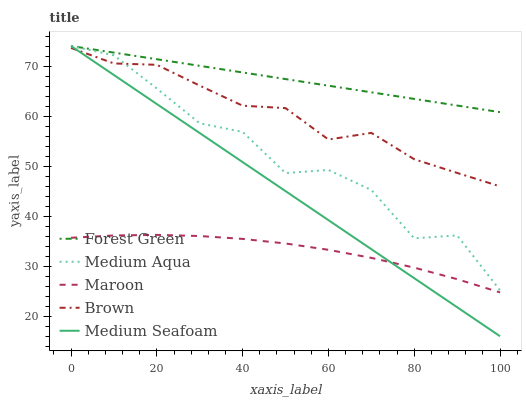Does Maroon have the minimum area under the curve?
Answer yes or no. Yes. Does Forest Green have the maximum area under the curve?
Answer yes or no. Yes. Does Medium Aqua have the minimum area under the curve?
Answer yes or no. No. Does Medium Aqua have the maximum area under the curve?
Answer yes or no. No. Is Medium Seafoam the smoothest?
Answer yes or no. Yes. Is Medium Aqua the roughest?
Answer yes or no. Yes. Is Forest Green the smoothest?
Answer yes or no. No. Is Forest Green the roughest?
Answer yes or no. No. Does Medium Seafoam have the lowest value?
Answer yes or no. Yes. Does Medium Aqua have the lowest value?
Answer yes or no. No. Does Medium Seafoam have the highest value?
Answer yes or no. Yes. Does Maroon have the highest value?
Answer yes or no. No. Is Brown less than Forest Green?
Answer yes or no. Yes. Is Medium Aqua greater than Maroon?
Answer yes or no. Yes. Does Medium Aqua intersect Brown?
Answer yes or no. Yes. Is Medium Aqua less than Brown?
Answer yes or no. No. Is Medium Aqua greater than Brown?
Answer yes or no. No. Does Brown intersect Forest Green?
Answer yes or no. No. 